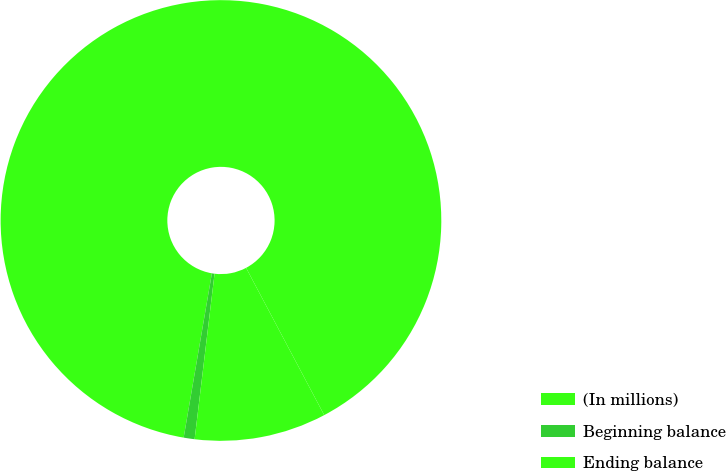Convert chart. <chart><loc_0><loc_0><loc_500><loc_500><pie_chart><fcel>(In millions)<fcel>Beginning balance<fcel>Ending balance<nl><fcel>89.52%<fcel>0.8%<fcel>9.67%<nl></chart> 